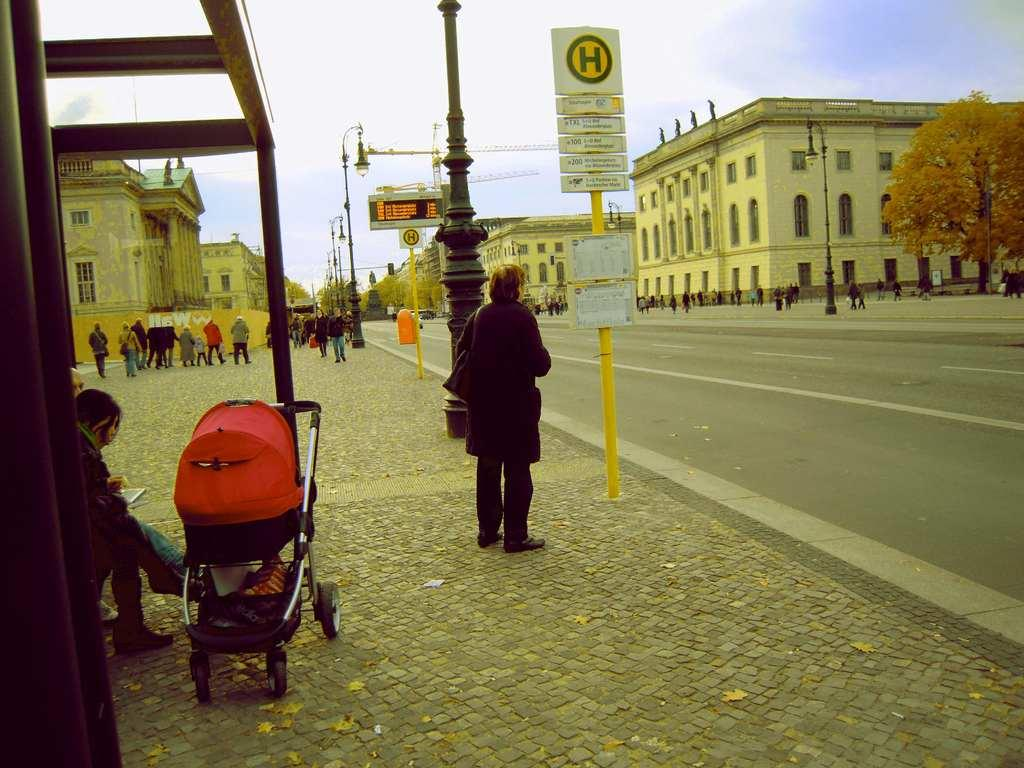Who or what can be seen in the image? There are people in the image. What type of structures are visible in the image? There are buildings in the image. What type of lighting is present in the image? Street lamps are present in the image. What is the purpose of the sign pole in the image? The sign pole is likely used for displaying signs or advertisements. What can be seen in the background of the image? The sky is visible in the image. What color of paint is being used to rest on the branch in the image? There is no paint or branch present in the image. 